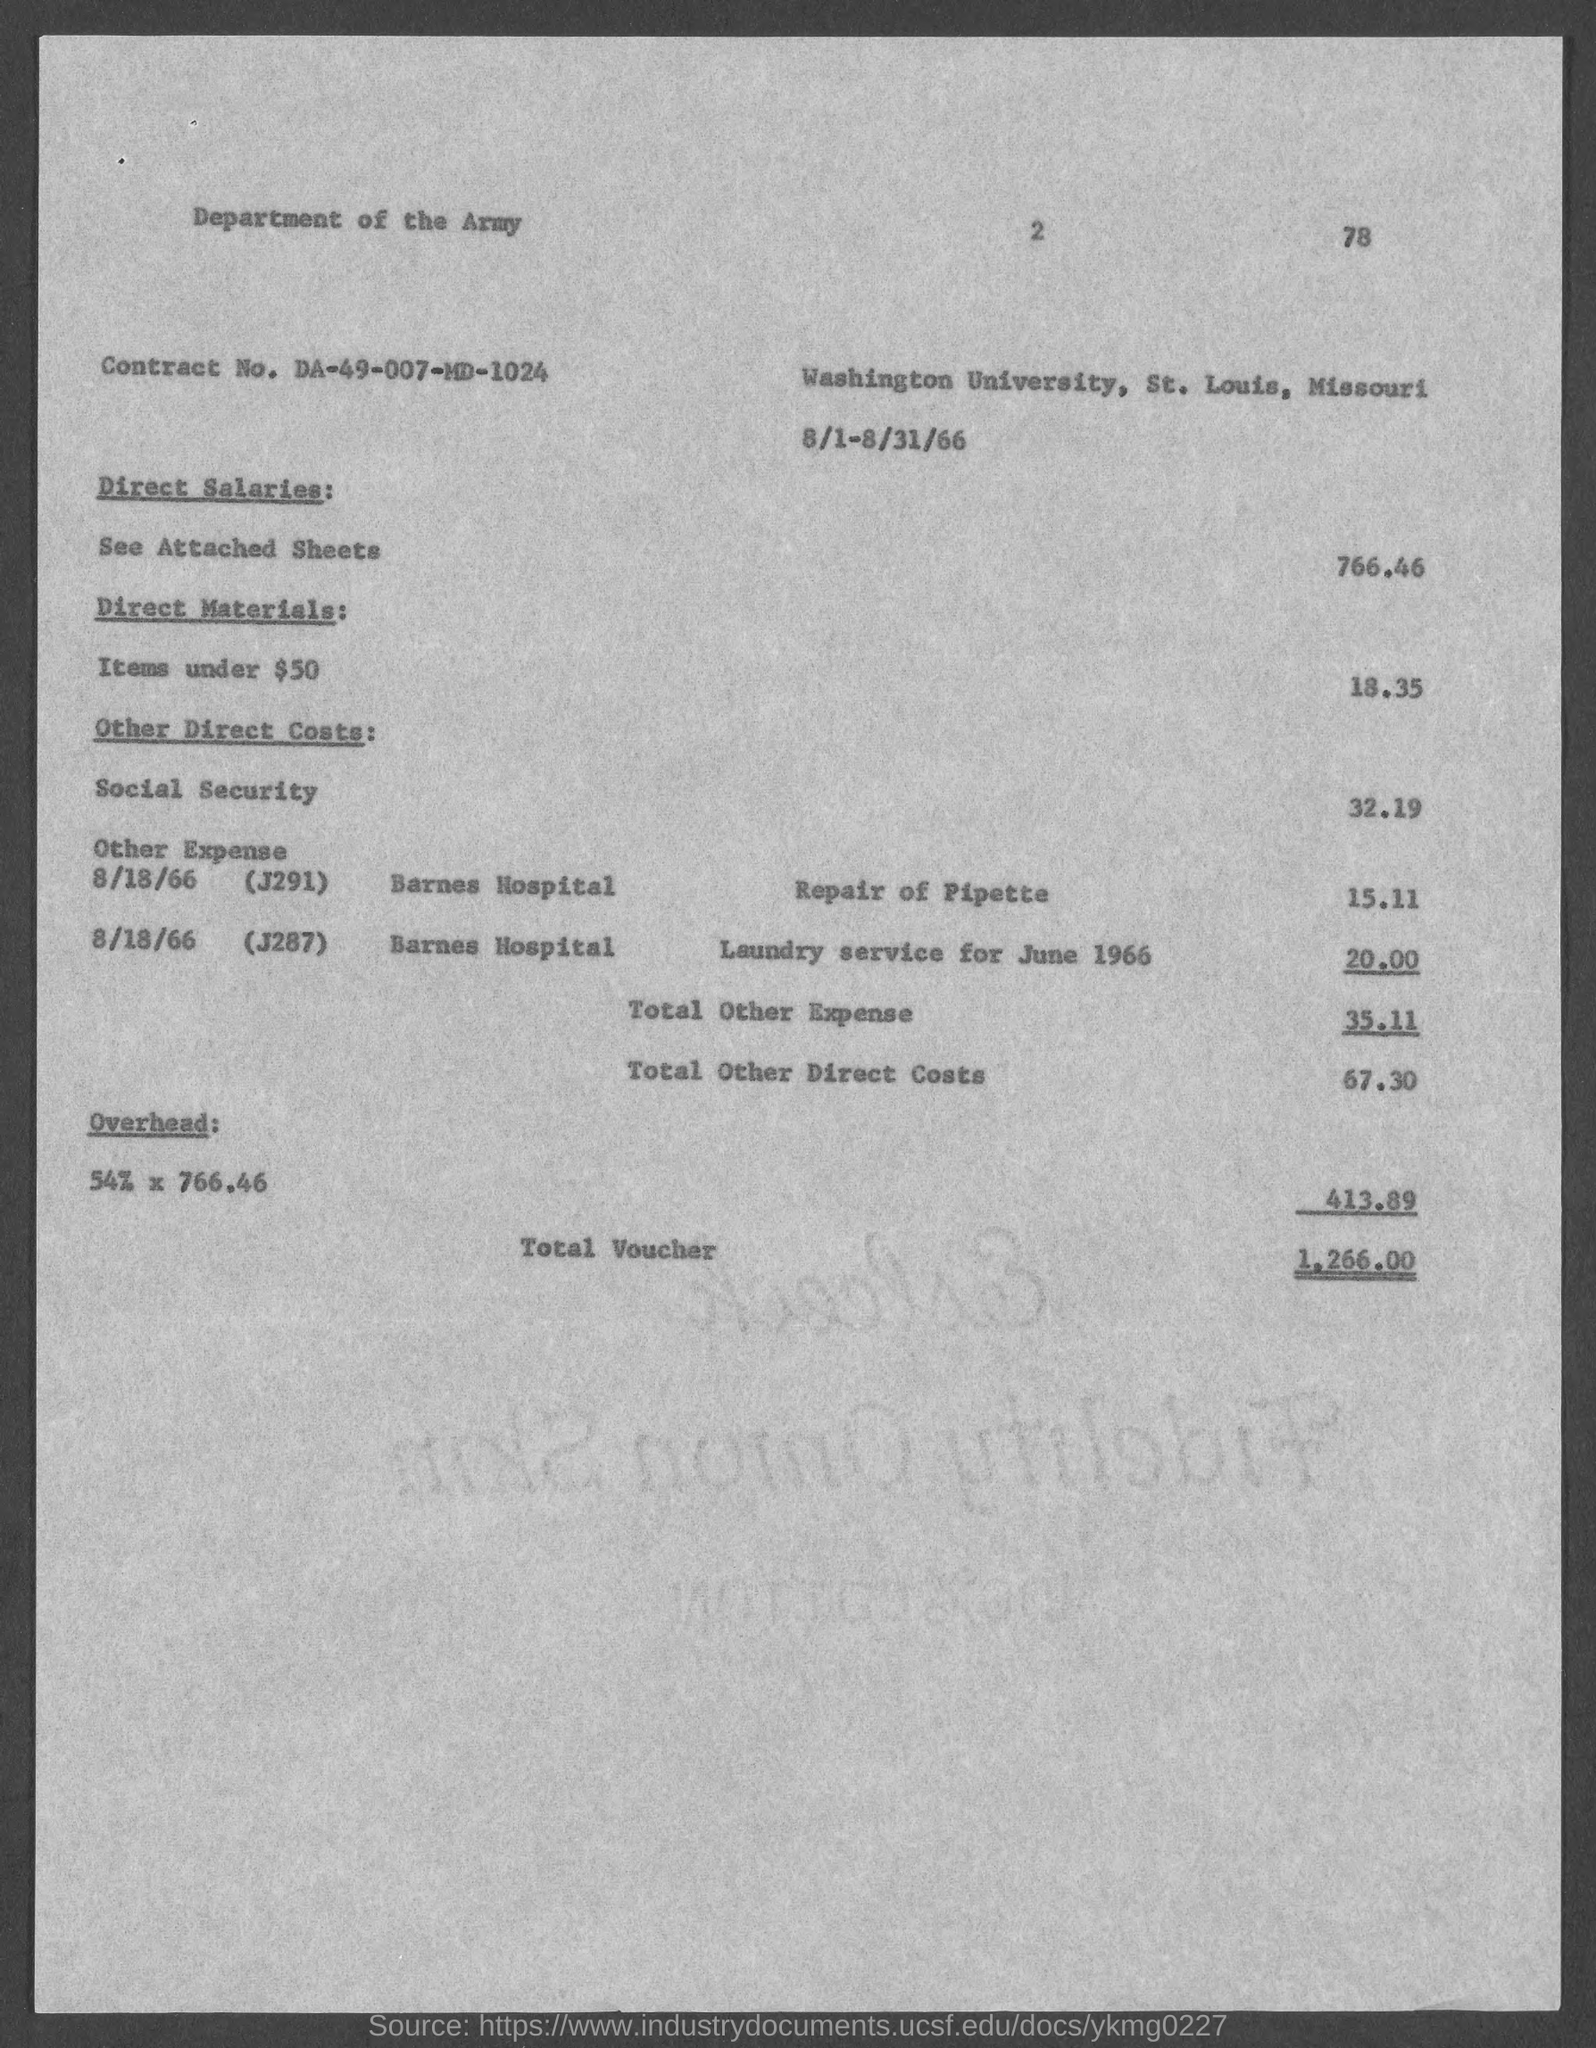Draw attention to some important aspects in this diagram. There is a total of 1,266.00 vouchers. The contract number is DA-49-007-MD-1024. 